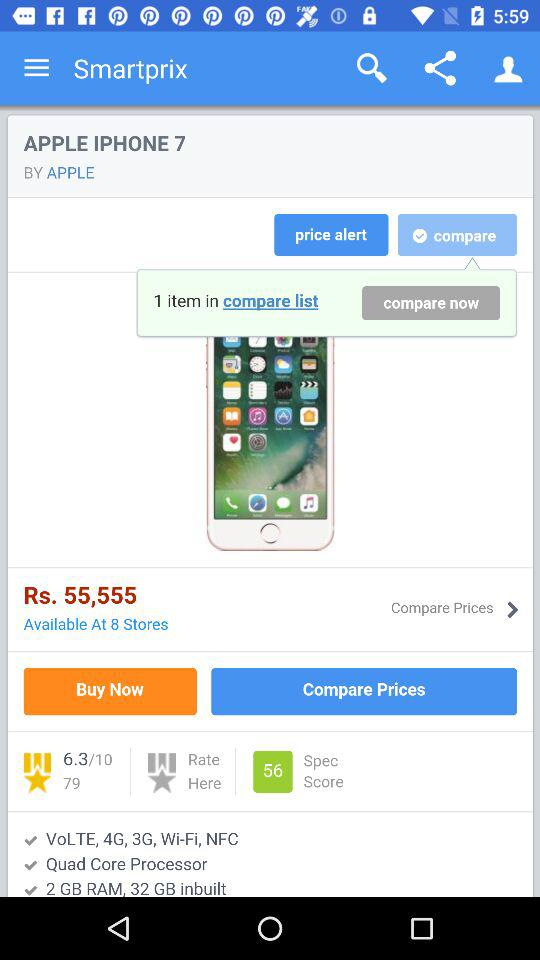What is the rating of the iPhone 7 out of 10? The rating is 6.3. 